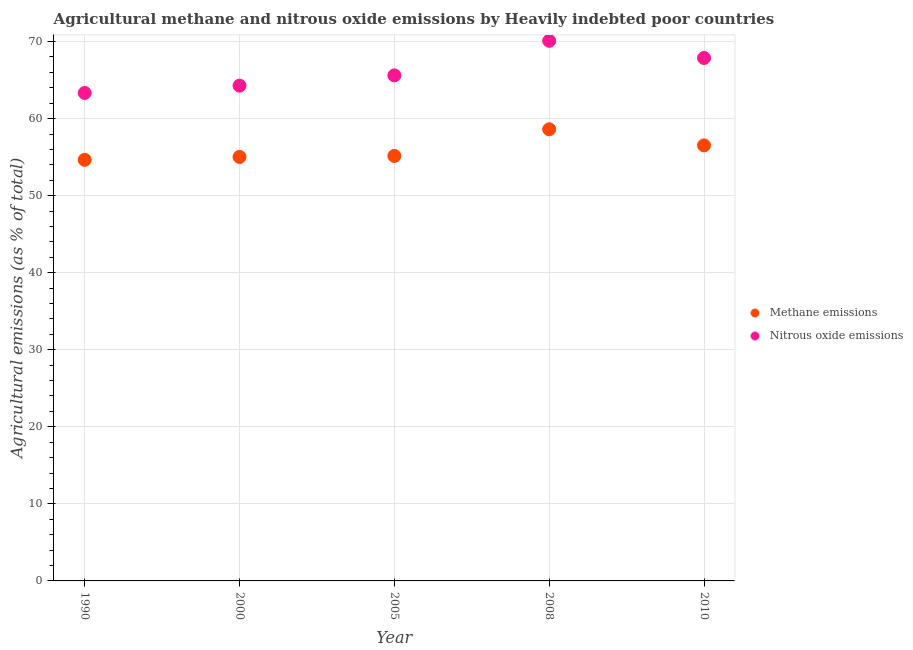How many different coloured dotlines are there?
Your response must be concise. 2. Is the number of dotlines equal to the number of legend labels?
Ensure brevity in your answer.  Yes. What is the amount of methane emissions in 2010?
Your answer should be compact. 56.52. Across all years, what is the maximum amount of nitrous oxide emissions?
Make the answer very short. 70.09. Across all years, what is the minimum amount of methane emissions?
Provide a short and direct response. 54.65. In which year was the amount of nitrous oxide emissions minimum?
Ensure brevity in your answer.  1990. What is the total amount of nitrous oxide emissions in the graph?
Keep it short and to the point. 331.17. What is the difference between the amount of methane emissions in 1990 and that in 2000?
Offer a very short reply. -0.38. What is the difference between the amount of methane emissions in 1990 and the amount of nitrous oxide emissions in 2000?
Make the answer very short. -9.63. What is the average amount of methane emissions per year?
Provide a succinct answer. 55.99. In the year 2000, what is the difference between the amount of methane emissions and amount of nitrous oxide emissions?
Give a very brief answer. -9.25. What is the ratio of the amount of nitrous oxide emissions in 1990 to that in 2000?
Ensure brevity in your answer.  0.99. Is the amount of nitrous oxide emissions in 1990 less than that in 2005?
Your response must be concise. Yes. Is the difference between the amount of nitrous oxide emissions in 2005 and 2010 greater than the difference between the amount of methane emissions in 2005 and 2010?
Offer a terse response. No. What is the difference between the highest and the second highest amount of nitrous oxide emissions?
Your response must be concise. 2.23. What is the difference between the highest and the lowest amount of nitrous oxide emissions?
Your answer should be compact. 6.76. Is the sum of the amount of methane emissions in 1990 and 2010 greater than the maximum amount of nitrous oxide emissions across all years?
Ensure brevity in your answer.  Yes. How many dotlines are there?
Offer a very short reply. 2. How many years are there in the graph?
Offer a very short reply. 5. Are the values on the major ticks of Y-axis written in scientific E-notation?
Your response must be concise. No. Does the graph contain any zero values?
Offer a very short reply. No. Does the graph contain grids?
Provide a succinct answer. Yes. How many legend labels are there?
Your answer should be compact. 2. How are the legend labels stacked?
Make the answer very short. Vertical. What is the title of the graph?
Offer a terse response. Agricultural methane and nitrous oxide emissions by Heavily indebted poor countries. What is the label or title of the Y-axis?
Offer a very short reply. Agricultural emissions (as % of total). What is the Agricultural emissions (as % of total) in Methane emissions in 1990?
Offer a very short reply. 54.65. What is the Agricultural emissions (as % of total) in Nitrous oxide emissions in 1990?
Ensure brevity in your answer.  63.33. What is the Agricultural emissions (as % of total) of Methane emissions in 2000?
Provide a succinct answer. 55.03. What is the Agricultural emissions (as % of total) in Nitrous oxide emissions in 2000?
Your answer should be compact. 64.27. What is the Agricultural emissions (as % of total) in Methane emissions in 2005?
Give a very brief answer. 55.15. What is the Agricultural emissions (as % of total) of Nitrous oxide emissions in 2005?
Give a very brief answer. 65.61. What is the Agricultural emissions (as % of total) of Methane emissions in 2008?
Your response must be concise. 58.61. What is the Agricultural emissions (as % of total) of Nitrous oxide emissions in 2008?
Offer a very short reply. 70.09. What is the Agricultural emissions (as % of total) of Methane emissions in 2010?
Keep it short and to the point. 56.52. What is the Agricultural emissions (as % of total) of Nitrous oxide emissions in 2010?
Keep it short and to the point. 67.87. Across all years, what is the maximum Agricultural emissions (as % of total) of Methane emissions?
Ensure brevity in your answer.  58.61. Across all years, what is the maximum Agricultural emissions (as % of total) of Nitrous oxide emissions?
Your answer should be compact. 70.09. Across all years, what is the minimum Agricultural emissions (as % of total) in Methane emissions?
Ensure brevity in your answer.  54.65. Across all years, what is the minimum Agricultural emissions (as % of total) of Nitrous oxide emissions?
Offer a terse response. 63.33. What is the total Agricultural emissions (as % of total) in Methane emissions in the graph?
Provide a short and direct response. 279.96. What is the total Agricultural emissions (as % of total) in Nitrous oxide emissions in the graph?
Offer a terse response. 331.17. What is the difference between the Agricultural emissions (as % of total) in Methane emissions in 1990 and that in 2000?
Provide a succinct answer. -0.38. What is the difference between the Agricultural emissions (as % of total) of Nitrous oxide emissions in 1990 and that in 2000?
Make the answer very short. -0.94. What is the difference between the Agricultural emissions (as % of total) of Methane emissions in 1990 and that in 2005?
Give a very brief answer. -0.51. What is the difference between the Agricultural emissions (as % of total) of Nitrous oxide emissions in 1990 and that in 2005?
Make the answer very short. -2.28. What is the difference between the Agricultural emissions (as % of total) in Methane emissions in 1990 and that in 2008?
Offer a very short reply. -3.97. What is the difference between the Agricultural emissions (as % of total) of Nitrous oxide emissions in 1990 and that in 2008?
Give a very brief answer. -6.76. What is the difference between the Agricultural emissions (as % of total) in Methane emissions in 1990 and that in 2010?
Make the answer very short. -1.87. What is the difference between the Agricultural emissions (as % of total) in Nitrous oxide emissions in 1990 and that in 2010?
Make the answer very short. -4.54. What is the difference between the Agricultural emissions (as % of total) of Methane emissions in 2000 and that in 2005?
Your answer should be very brief. -0.13. What is the difference between the Agricultural emissions (as % of total) of Nitrous oxide emissions in 2000 and that in 2005?
Offer a terse response. -1.33. What is the difference between the Agricultural emissions (as % of total) in Methane emissions in 2000 and that in 2008?
Keep it short and to the point. -3.59. What is the difference between the Agricultural emissions (as % of total) in Nitrous oxide emissions in 2000 and that in 2008?
Give a very brief answer. -5.82. What is the difference between the Agricultural emissions (as % of total) of Methane emissions in 2000 and that in 2010?
Keep it short and to the point. -1.49. What is the difference between the Agricultural emissions (as % of total) in Nitrous oxide emissions in 2000 and that in 2010?
Ensure brevity in your answer.  -3.59. What is the difference between the Agricultural emissions (as % of total) of Methane emissions in 2005 and that in 2008?
Offer a very short reply. -3.46. What is the difference between the Agricultural emissions (as % of total) of Nitrous oxide emissions in 2005 and that in 2008?
Make the answer very short. -4.49. What is the difference between the Agricultural emissions (as % of total) of Methane emissions in 2005 and that in 2010?
Offer a very short reply. -1.36. What is the difference between the Agricultural emissions (as % of total) in Nitrous oxide emissions in 2005 and that in 2010?
Provide a short and direct response. -2.26. What is the difference between the Agricultural emissions (as % of total) of Methane emissions in 2008 and that in 2010?
Ensure brevity in your answer.  2.09. What is the difference between the Agricultural emissions (as % of total) in Nitrous oxide emissions in 2008 and that in 2010?
Offer a terse response. 2.23. What is the difference between the Agricultural emissions (as % of total) of Methane emissions in 1990 and the Agricultural emissions (as % of total) of Nitrous oxide emissions in 2000?
Provide a short and direct response. -9.63. What is the difference between the Agricultural emissions (as % of total) in Methane emissions in 1990 and the Agricultural emissions (as % of total) in Nitrous oxide emissions in 2005?
Offer a terse response. -10.96. What is the difference between the Agricultural emissions (as % of total) in Methane emissions in 1990 and the Agricultural emissions (as % of total) in Nitrous oxide emissions in 2008?
Provide a succinct answer. -15.45. What is the difference between the Agricultural emissions (as % of total) of Methane emissions in 1990 and the Agricultural emissions (as % of total) of Nitrous oxide emissions in 2010?
Offer a very short reply. -13.22. What is the difference between the Agricultural emissions (as % of total) in Methane emissions in 2000 and the Agricultural emissions (as % of total) in Nitrous oxide emissions in 2005?
Provide a succinct answer. -10.58. What is the difference between the Agricultural emissions (as % of total) in Methane emissions in 2000 and the Agricultural emissions (as % of total) in Nitrous oxide emissions in 2008?
Provide a succinct answer. -15.07. What is the difference between the Agricultural emissions (as % of total) in Methane emissions in 2000 and the Agricultural emissions (as % of total) in Nitrous oxide emissions in 2010?
Give a very brief answer. -12.84. What is the difference between the Agricultural emissions (as % of total) in Methane emissions in 2005 and the Agricultural emissions (as % of total) in Nitrous oxide emissions in 2008?
Offer a very short reply. -14.94. What is the difference between the Agricultural emissions (as % of total) in Methane emissions in 2005 and the Agricultural emissions (as % of total) in Nitrous oxide emissions in 2010?
Offer a terse response. -12.71. What is the difference between the Agricultural emissions (as % of total) in Methane emissions in 2008 and the Agricultural emissions (as % of total) in Nitrous oxide emissions in 2010?
Keep it short and to the point. -9.26. What is the average Agricultural emissions (as % of total) in Methane emissions per year?
Keep it short and to the point. 55.99. What is the average Agricultural emissions (as % of total) in Nitrous oxide emissions per year?
Keep it short and to the point. 66.23. In the year 1990, what is the difference between the Agricultural emissions (as % of total) in Methane emissions and Agricultural emissions (as % of total) in Nitrous oxide emissions?
Provide a short and direct response. -8.68. In the year 2000, what is the difference between the Agricultural emissions (as % of total) in Methane emissions and Agricultural emissions (as % of total) in Nitrous oxide emissions?
Give a very brief answer. -9.25. In the year 2005, what is the difference between the Agricultural emissions (as % of total) in Methane emissions and Agricultural emissions (as % of total) in Nitrous oxide emissions?
Your answer should be compact. -10.45. In the year 2008, what is the difference between the Agricultural emissions (as % of total) of Methane emissions and Agricultural emissions (as % of total) of Nitrous oxide emissions?
Your answer should be very brief. -11.48. In the year 2010, what is the difference between the Agricultural emissions (as % of total) of Methane emissions and Agricultural emissions (as % of total) of Nitrous oxide emissions?
Offer a very short reply. -11.35. What is the ratio of the Agricultural emissions (as % of total) of Nitrous oxide emissions in 1990 to that in 2005?
Your answer should be very brief. 0.97. What is the ratio of the Agricultural emissions (as % of total) in Methane emissions in 1990 to that in 2008?
Offer a very short reply. 0.93. What is the ratio of the Agricultural emissions (as % of total) of Nitrous oxide emissions in 1990 to that in 2008?
Your response must be concise. 0.9. What is the ratio of the Agricultural emissions (as % of total) of Methane emissions in 1990 to that in 2010?
Keep it short and to the point. 0.97. What is the ratio of the Agricultural emissions (as % of total) in Nitrous oxide emissions in 1990 to that in 2010?
Your answer should be very brief. 0.93. What is the ratio of the Agricultural emissions (as % of total) of Nitrous oxide emissions in 2000 to that in 2005?
Ensure brevity in your answer.  0.98. What is the ratio of the Agricultural emissions (as % of total) of Methane emissions in 2000 to that in 2008?
Ensure brevity in your answer.  0.94. What is the ratio of the Agricultural emissions (as % of total) in Nitrous oxide emissions in 2000 to that in 2008?
Offer a very short reply. 0.92. What is the ratio of the Agricultural emissions (as % of total) of Methane emissions in 2000 to that in 2010?
Offer a terse response. 0.97. What is the ratio of the Agricultural emissions (as % of total) of Nitrous oxide emissions in 2000 to that in 2010?
Ensure brevity in your answer.  0.95. What is the ratio of the Agricultural emissions (as % of total) in Methane emissions in 2005 to that in 2008?
Your response must be concise. 0.94. What is the ratio of the Agricultural emissions (as % of total) in Nitrous oxide emissions in 2005 to that in 2008?
Give a very brief answer. 0.94. What is the ratio of the Agricultural emissions (as % of total) of Methane emissions in 2005 to that in 2010?
Provide a succinct answer. 0.98. What is the ratio of the Agricultural emissions (as % of total) of Nitrous oxide emissions in 2005 to that in 2010?
Provide a short and direct response. 0.97. What is the ratio of the Agricultural emissions (as % of total) in Nitrous oxide emissions in 2008 to that in 2010?
Your answer should be compact. 1.03. What is the difference between the highest and the second highest Agricultural emissions (as % of total) of Methane emissions?
Give a very brief answer. 2.09. What is the difference between the highest and the second highest Agricultural emissions (as % of total) in Nitrous oxide emissions?
Your response must be concise. 2.23. What is the difference between the highest and the lowest Agricultural emissions (as % of total) in Methane emissions?
Provide a succinct answer. 3.97. What is the difference between the highest and the lowest Agricultural emissions (as % of total) of Nitrous oxide emissions?
Provide a succinct answer. 6.76. 